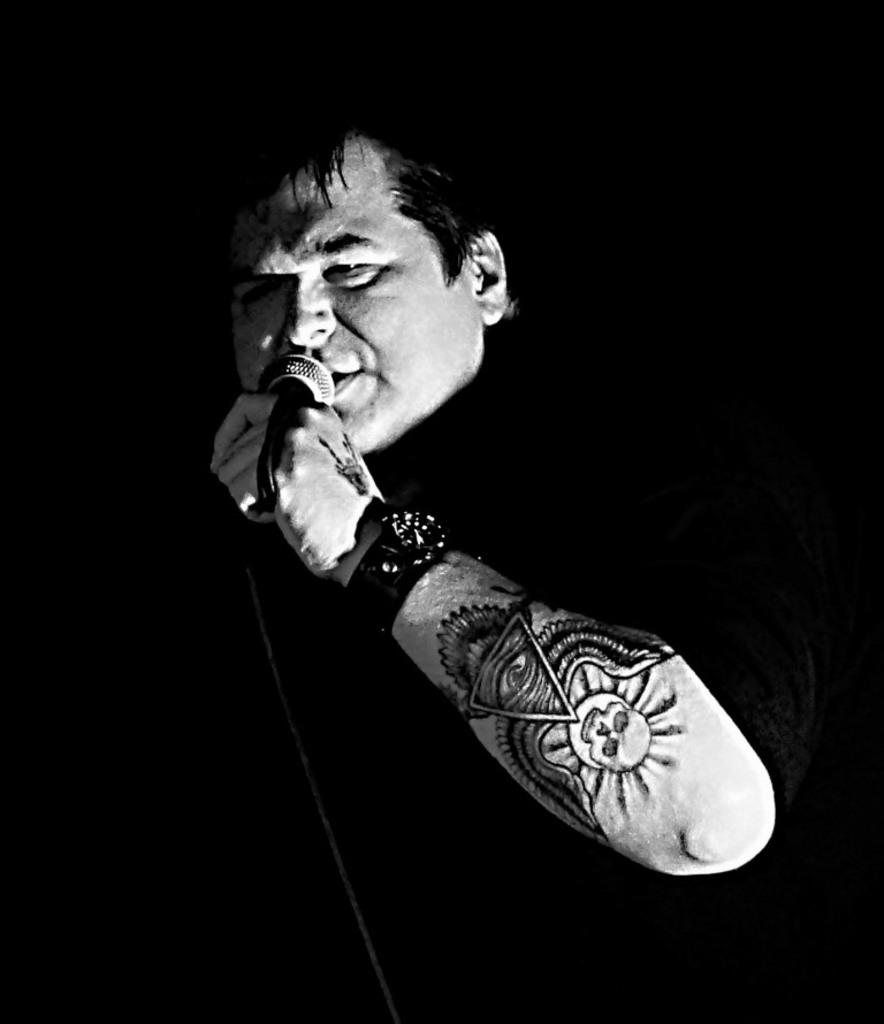What is the main subject in the foreground of the image? There is a person in the foreground of the image. What is the person holding in the image? The person is holding a microphone. Can you describe any distinguishing features of the person in the image? The person has a tattoo on their right hand. What type of attraction can be seen in the background of the image? There is no attraction visible in the image; it only features a person holding a microphone with a tattoo on their right hand. 